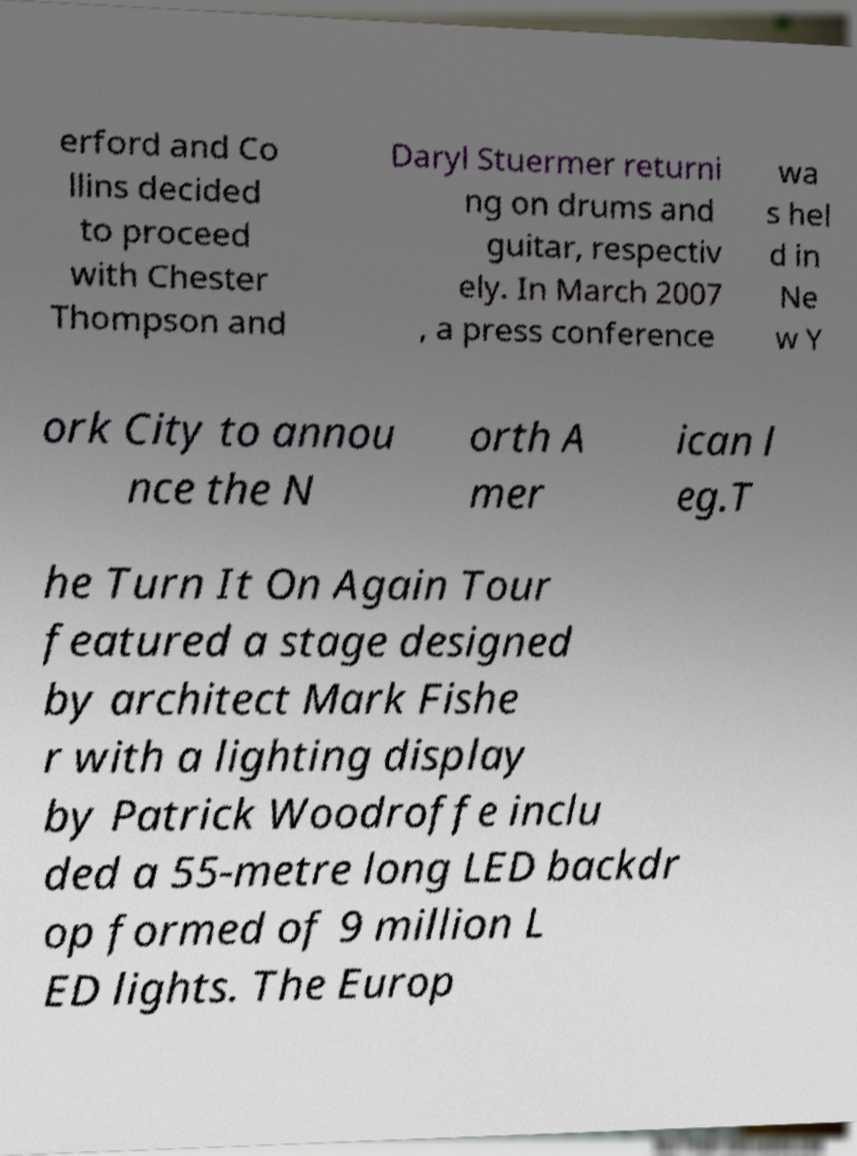Please identify and transcribe the text found in this image. erford and Co llins decided to proceed with Chester Thompson and Daryl Stuermer returni ng on drums and guitar, respectiv ely. In March 2007 , a press conference wa s hel d in Ne w Y ork City to annou nce the N orth A mer ican l eg.T he Turn It On Again Tour featured a stage designed by architect Mark Fishe r with a lighting display by Patrick Woodroffe inclu ded a 55-metre long LED backdr op formed of 9 million L ED lights. The Europ 